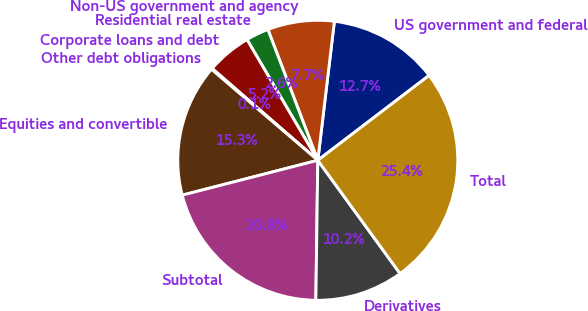Convert chart. <chart><loc_0><loc_0><loc_500><loc_500><pie_chart><fcel>US government and federal<fcel>Non-US government and agency<fcel>Residential real estate<fcel>Corporate loans and debt<fcel>Other debt obligations<fcel>Equities and convertible<fcel>Subtotal<fcel>Derivatives<fcel>Total<nl><fcel>12.74%<fcel>7.69%<fcel>2.64%<fcel>5.17%<fcel>0.12%<fcel>15.27%<fcel>20.77%<fcel>10.22%<fcel>25.37%<nl></chart> 